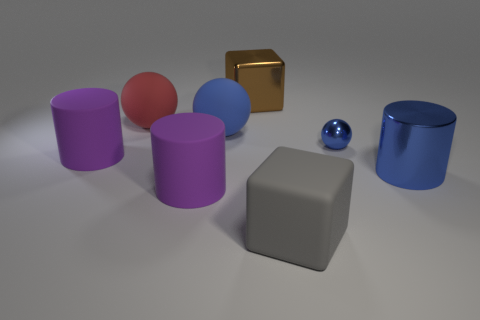How many blue spheres must be subtracted to get 1 blue spheres? 1 Subtract all matte cylinders. How many cylinders are left? 1 Add 2 metallic objects. How many objects exist? 10 Subtract all cubes. How many objects are left? 6 Subtract 0 red blocks. How many objects are left? 8 Subtract all tiny blue objects. Subtract all big blue rubber things. How many objects are left? 6 Add 5 purple rubber things. How many purple rubber things are left? 7 Add 2 metallic cylinders. How many metallic cylinders exist? 3 